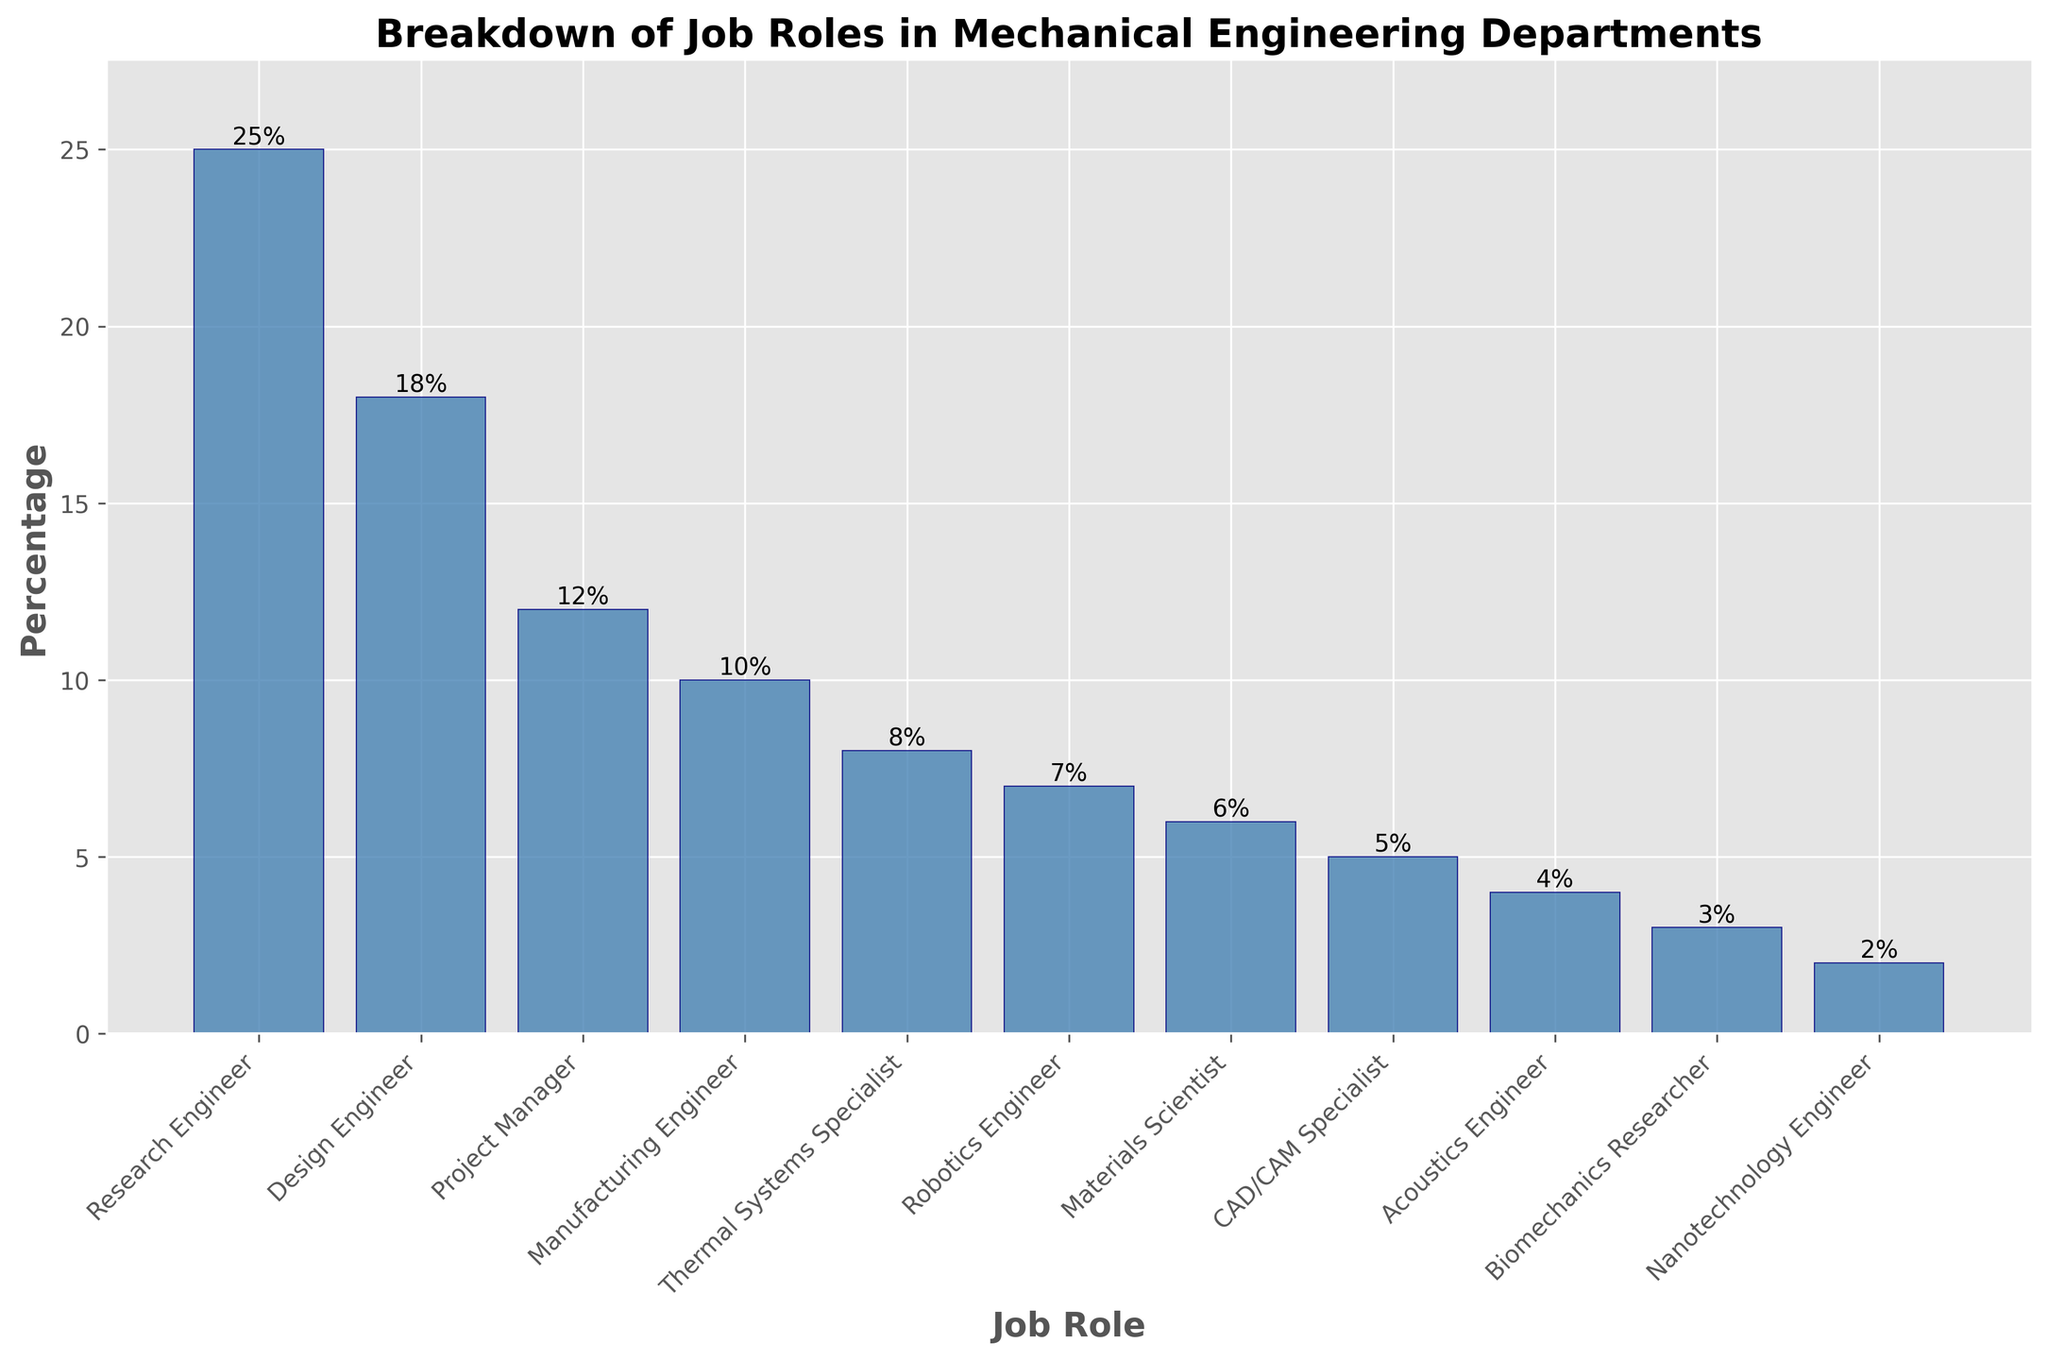What job role has the highest percentage? The tallest bar corresponds to the job role with the highest percentage, which is at 25%. This role is labeled "Research Engineer" at the top of the bar.
Answer: Research Engineer What is the combined percentage for Design Engineers and CAD/CAM Specialists? First, identify the bar heights by looking at the top labels: Design Engineer is at 18% and CAD/CAM Specialist is at 5%. Sum these percentages: 18 + 5 = 23%.
Answer: 23% How many job roles have a percentage below 10%? Count all bars with height labels below 10%: 1 (Thermal Systems Specialist), 2 (Robotics Engineer), 3 (Materials Scientist), 4 (CAD/CAM Specialist), 5 (Acoustics Engineer), 6 (Biomechanics Researcher), 7 (Nanotechnology Engineer).
Answer: 7 Is the percentage of Project Managers greater than Manufacturing Engineers? Compare the heights of the bars: Project Manager is at 12% and Manufacturing Engineer is at 10%. Since 12% is greater than 10%, the answer is yes.
Answer: Yes How much lower is the percentage of Nanotechnology Engineers compared to Materials Scientists? Identify the bar heights and subtract: Materials Scientist is at 6% and Nanotechnology Engineer is at 2%. The difference is 6 - 2 = 4%.
Answer: 4% What is the average percentage of Robotics Engineers and Acoustics Engineers? First, identify the bar heights: Robotics Engineer is at 7% and Acoustics Engineer is at 4%. Average these values: (7 + 4) / 2 = 5.5%.
Answer: 5.5% Which job role has the second highest percentage? The second tallest bar corresponds to the job role with the second highest percentage, which is labeled at 18%. This role is "Design Engineer".
Answer: Design Engineer What is the ratio of Research Engineers to Nanotechnology Engineers? Identify the percentages of both roles: Research Engineer is at 25% and Nanotechnology Engineer is at 2%. The ratio is 25 / 2 = 12.5.
Answer: 12.5 If you were to create a team consisting of Project Managers and Robotics Engineers, what would be their total percentage? Identify the percentages: Project Manager is at 12% and Robotics Engineer is at 7%. Sum these percentages: 12 + 7 = 19%.
Answer: 19% Which has a higher percentage: Thermal Systems Specialists or Materials Scientists, and by how much? Compare the heights of the bars: Thermal Systems Specialist is at 8% and Materials Scientist is at 6%. Subtract the lower percentage from the higher one: 8 - 6 = 2%.
Answer: Thermal Systems Specialists by 2% 